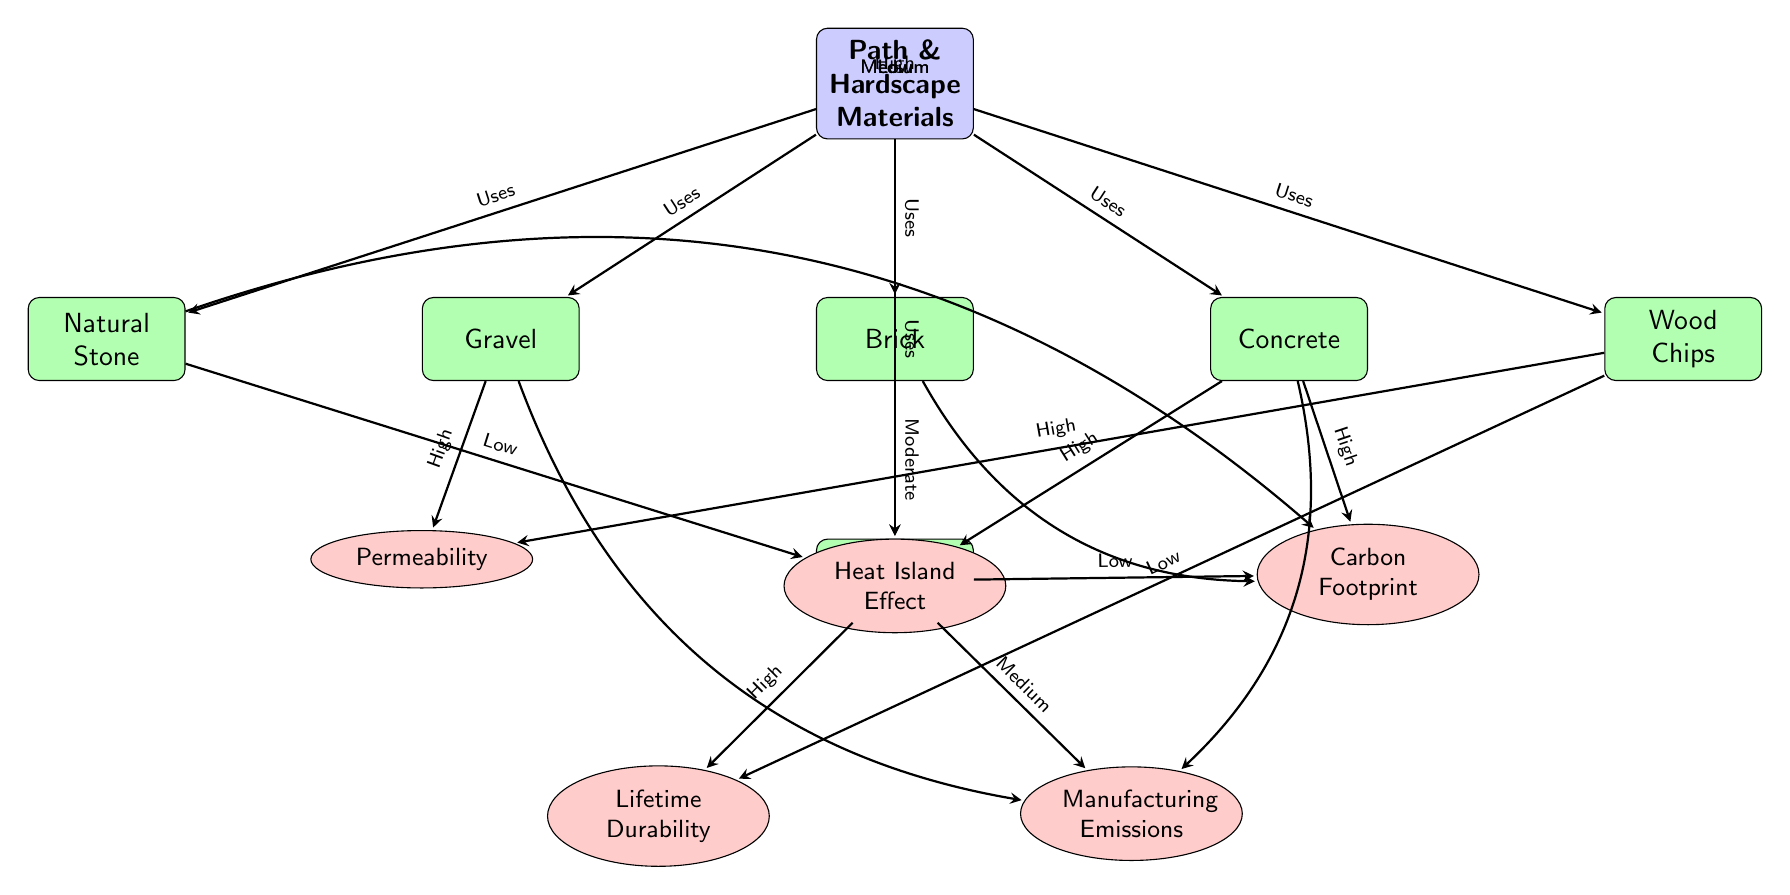What materials are listed in the diagram? The diagram includes materials that are directly connected to the main node labeled "Path & Hardscape Materials." These materials are Gravel, Brick, Concrete, Natural Stone, Wood Chips, and Recycled Rubber.
Answer: Gravel, Brick, Concrete, Natural Stone, Wood Chips, Recycled Rubber Which material has the highest heat island effect? The arrows indicate the relationships and impact levels. Both Brick and Concrete are marked as having a high heat island effect. Among these, Concrete is also indicated as being high, making it the highest in terms of the heat island effect.
Answer: Concrete How many impacts are associated with Recycled Rubber? Recycled Rubber is connected to two impact nodes: Lifetime Durability and Manufacturing Emissions. Counting these connections shows that there are two impacts associated with Recycled Rubber.
Answer: 2 Which material has the lowest carbon footprint? The arrows from the materials to the impacts show that Recycled Rubber has a low carbon footprint. The specific connection to the carbon impact indicates its lower impact compared to the other materials.
Answer: Recycled Rubber What is the permeability impact rating for Gravel? The diagram shows an arrow leading from Gravel to the Permeability impact node, with a label indicating a "High" permeability rating. This specifies the nature of Gravel in terms of permeability.
Answer: High Which material has the highest manufacturing emissions? The connections from materials to emissions indicate that Concrete has a high rating for manufacturing emissions, as denoted by the corresponding arrow and label. This makes it the material with the highest manufacturing emissions.
Answer: Concrete How many materials directly influence the heat island effect? To find this, we refer to materials that connect to the heat impact node. They are Brick, Concrete, and Natural Stone. Hence, three materials have an influence on the heat island effect.
Answer: 3 Which material has the highest durability rating? Recycled Rubber shows a connection to the Lifetime Durability impact and is labeled with a "High" rating. Since this is the only material with such a high designation in this segment, it stands out as the highest.
Answer: Recycled Rubber What distinguishes Natural Stone in terms of impact compared to other materials? When examining the diagram, Natural Stone is connected to the heat island effect with a "Low" impact rating. This indicates that it has a lesser effect in this category compared to the other materials which mostly have higher ratings.
Answer: Low Heat Island Effect 